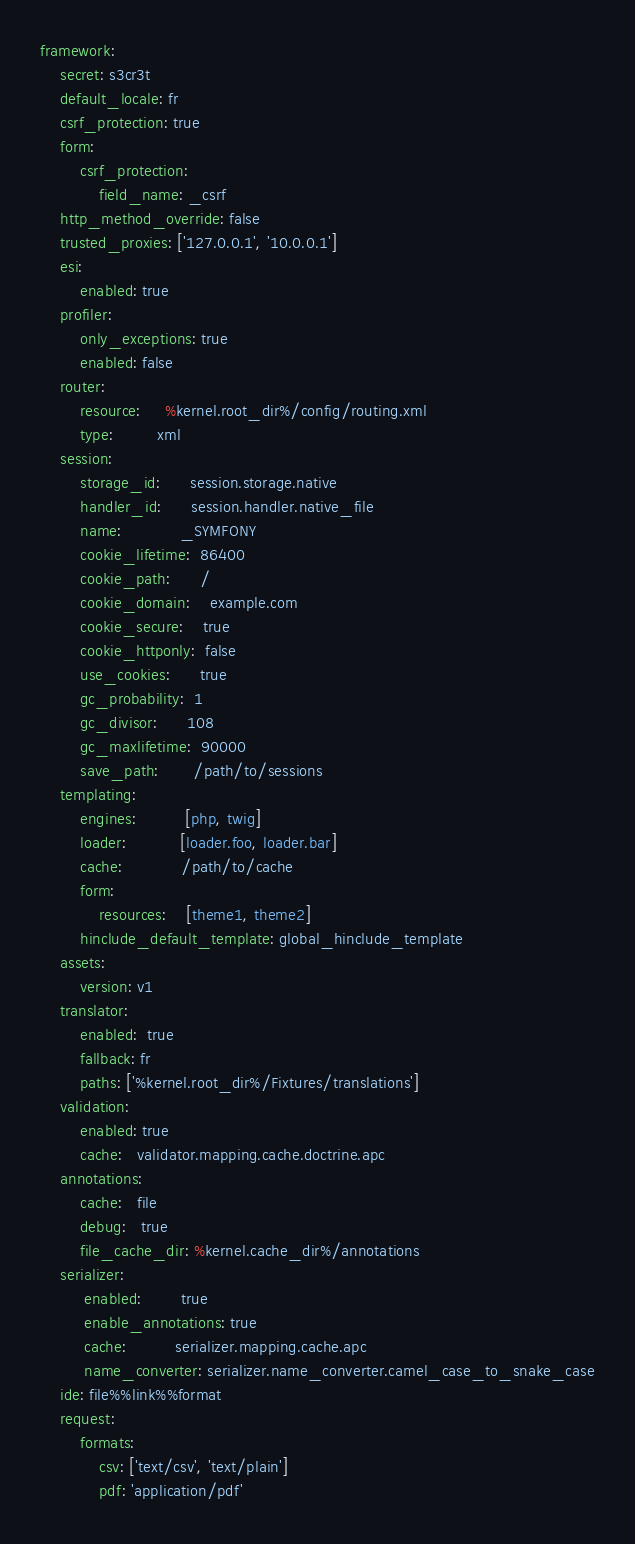<code> <loc_0><loc_0><loc_500><loc_500><_YAML_>framework:
    secret: s3cr3t
    default_locale: fr
    csrf_protection: true
    form:
        csrf_protection:
            field_name: _csrf
    http_method_override: false
    trusted_proxies: ['127.0.0.1', '10.0.0.1']
    esi:
        enabled: true
    profiler:
        only_exceptions: true
        enabled: false
    router:
        resource:     %kernel.root_dir%/config/routing.xml
        type:         xml
    session:
        storage_id:      session.storage.native
        handler_id:      session.handler.native_file
        name:            _SYMFONY
        cookie_lifetime:  86400
        cookie_path:      /
        cookie_domain:    example.com
        cookie_secure:    true
        cookie_httponly:  false
        use_cookies:      true
        gc_probability:  1
        gc_divisor:      108
        gc_maxlifetime:  90000
        save_path:       /path/to/sessions
    templating:
        engines:          [php, twig]
        loader:           [loader.foo, loader.bar]
        cache:            /path/to/cache
        form:
            resources:    [theme1, theme2]
        hinclude_default_template: global_hinclude_template
    assets:
        version: v1
    translator:
        enabled:  true
        fallback: fr
        paths: ['%kernel.root_dir%/Fixtures/translations']
    validation:
        enabled: true
        cache:   validator.mapping.cache.doctrine.apc
    annotations:
        cache:   file
        debug:   true
        file_cache_dir: %kernel.cache_dir%/annotations
    serializer:
         enabled:        true
         enable_annotations: true
         cache:          serializer.mapping.cache.apc
         name_converter: serializer.name_converter.camel_case_to_snake_case
    ide: file%%link%%format
    request:
        formats:
            csv: ['text/csv', 'text/plain']
            pdf: 'application/pdf'
</code> 